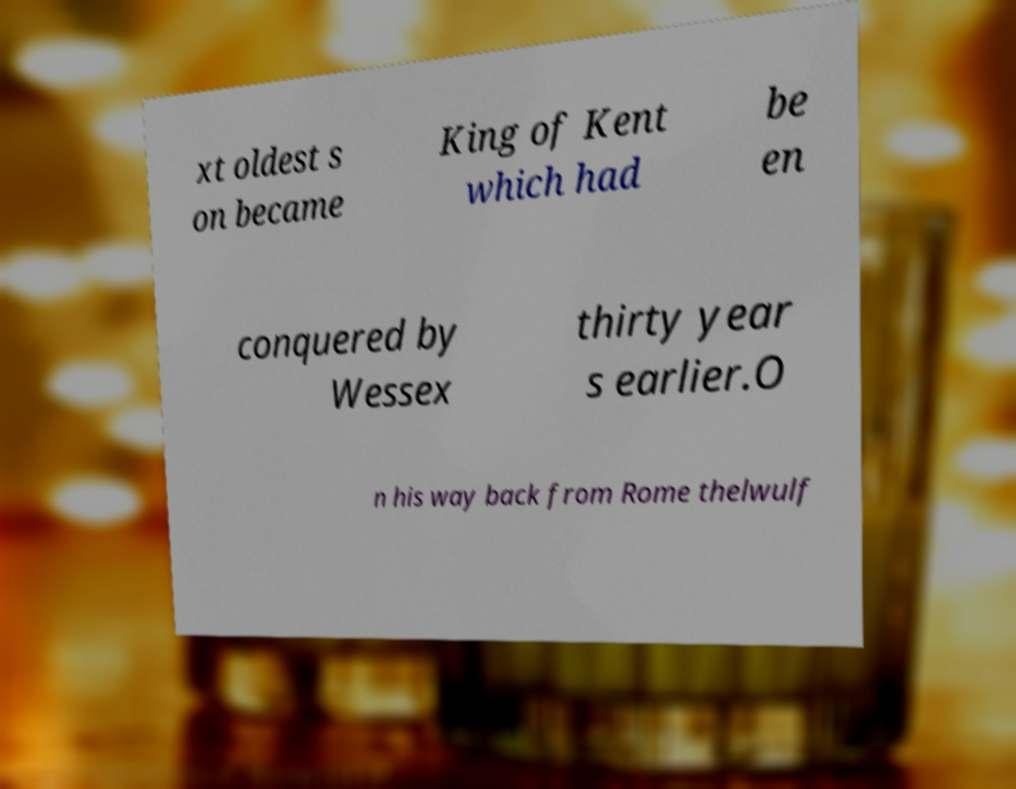Could you extract and type out the text from this image? xt oldest s on became King of Kent which had be en conquered by Wessex thirty year s earlier.O n his way back from Rome thelwulf 